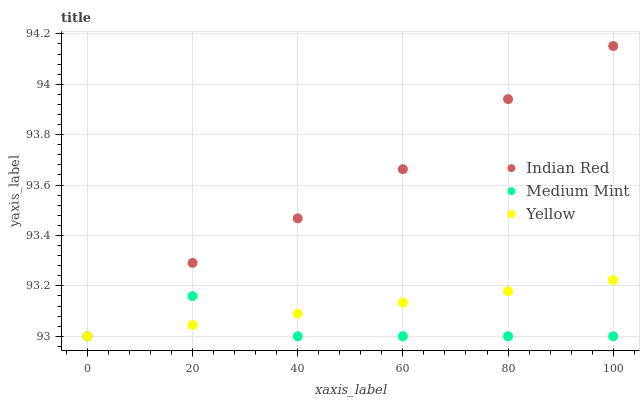Does Medium Mint have the minimum area under the curve?
Answer yes or no. Yes. Does Indian Red have the maximum area under the curve?
Answer yes or no. Yes. Does Yellow have the minimum area under the curve?
Answer yes or no. No. Does Yellow have the maximum area under the curve?
Answer yes or no. No. Is Yellow the smoothest?
Answer yes or no. Yes. Is Medium Mint the roughest?
Answer yes or no. Yes. Is Indian Red the smoothest?
Answer yes or no. No. Is Indian Red the roughest?
Answer yes or no. No. Does Medium Mint have the lowest value?
Answer yes or no. Yes. Does Indian Red have the highest value?
Answer yes or no. Yes. Does Yellow have the highest value?
Answer yes or no. No. Does Indian Red intersect Yellow?
Answer yes or no. Yes. Is Indian Red less than Yellow?
Answer yes or no. No. Is Indian Red greater than Yellow?
Answer yes or no. No. 